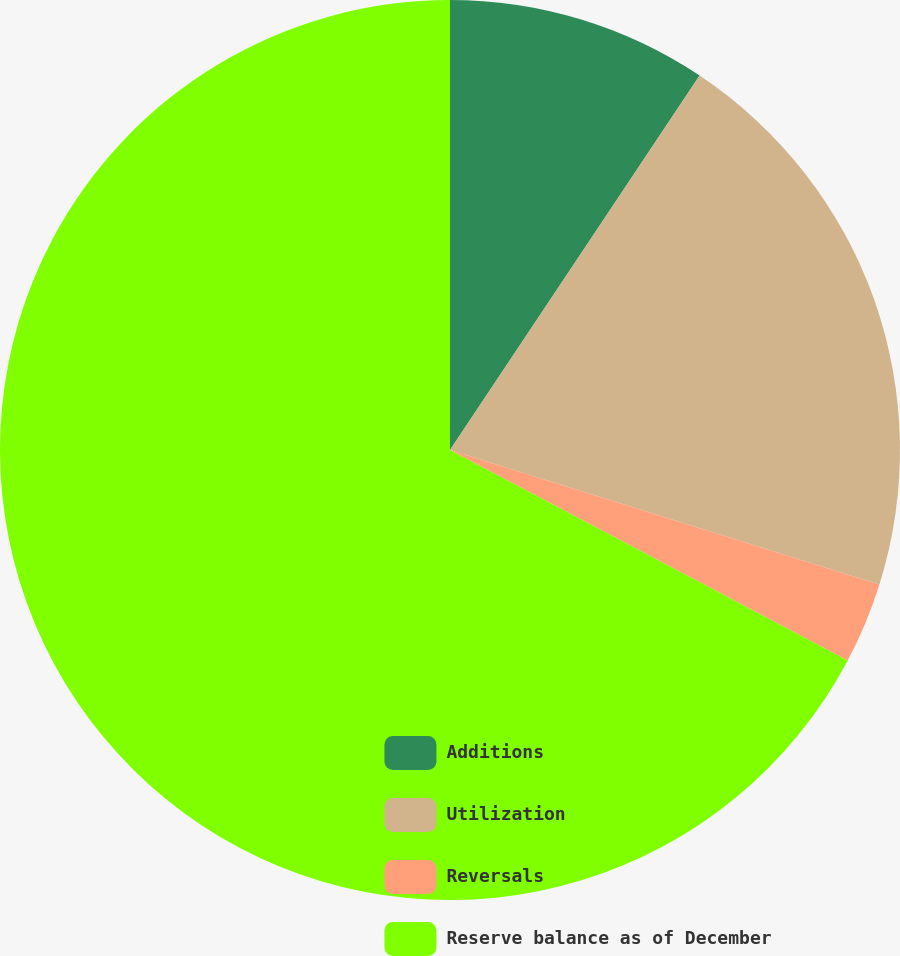Convert chart. <chart><loc_0><loc_0><loc_500><loc_500><pie_chart><fcel>Additions<fcel>Utilization<fcel>Reversals<fcel>Reserve balance as of December<nl><fcel>9.36%<fcel>20.47%<fcel>2.92%<fcel>67.25%<nl></chart> 